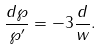Convert formula to latex. <formula><loc_0><loc_0><loc_500><loc_500>\frac { d \wp } { \wp ^ { \prime } } = - 3 \frac { d } { w } .</formula> 